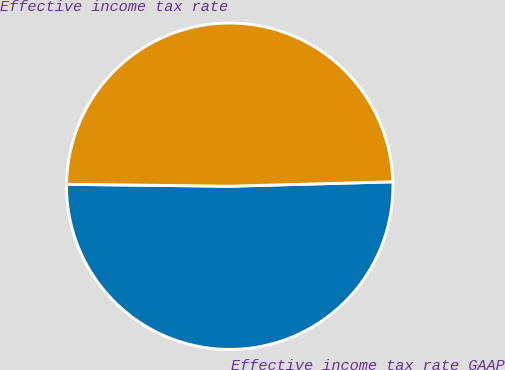Convert chart to OTSL. <chart><loc_0><loc_0><loc_500><loc_500><pie_chart><fcel>Effective income tax rate GAAP<fcel>Effective income tax rate<nl><fcel>50.62%<fcel>49.38%<nl></chart> 